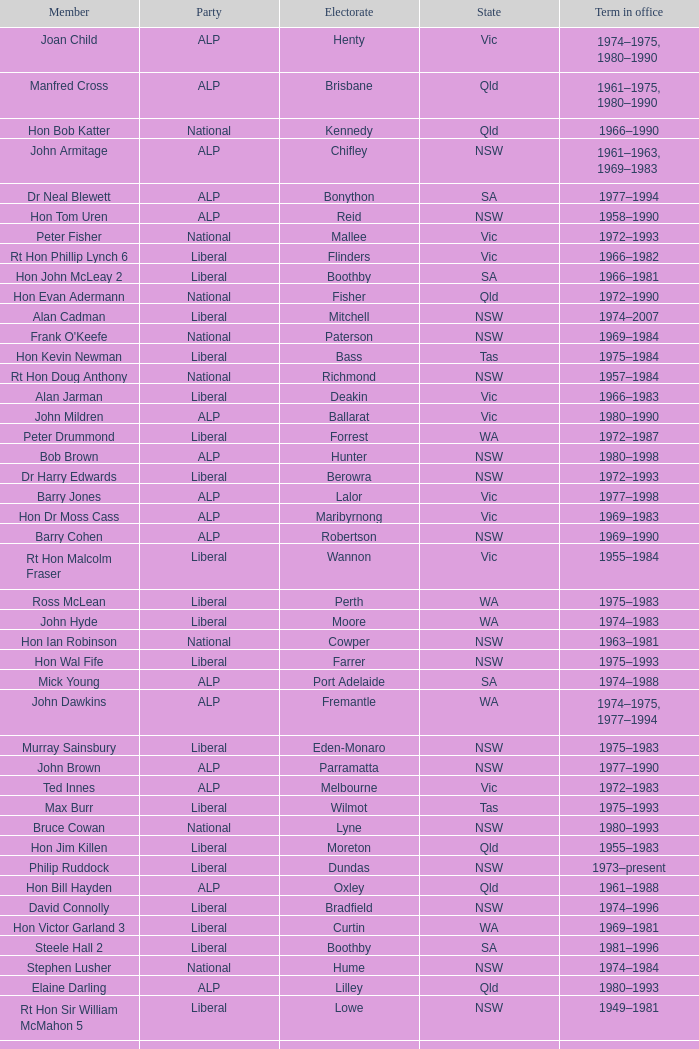Could you help me parse every detail presented in this table? {'header': ['Member', 'Party', 'Electorate', 'State', 'Term in office'], 'rows': [['Joan Child', 'ALP', 'Henty', 'Vic', '1974–1975, 1980–1990'], ['Manfred Cross', 'ALP', 'Brisbane', 'Qld', '1961–1975, 1980–1990'], ['Hon Bob Katter', 'National', 'Kennedy', 'Qld', '1966–1990'], ['John Armitage', 'ALP', 'Chifley', 'NSW', '1961–1963, 1969–1983'], ['Dr Neal Blewett', 'ALP', 'Bonython', 'SA', '1977–1994'], ['Hon Tom Uren', 'ALP', 'Reid', 'NSW', '1958–1990'], ['Peter Fisher', 'National', 'Mallee', 'Vic', '1972–1993'], ['Rt Hon Phillip Lynch 6', 'Liberal', 'Flinders', 'Vic', '1966–1982'], ['Hon John McLeay 2', 'Liberal', 'Boothby', 'SA', '1966–1981'], ['Hon Evan Adermann', 'National', 'Fisher', 'Qld', '1972–1990'], ['Alan Cadman', 'Liberal', 'Mitchell', 'NSW', '1974–2007'], ["Frank O'Keefe", 'National', 'Paterson', 'NSW', '1969–1984'], ['Hon Kevin Newman', 'Liberal', 'Bass', 'Tas', '1975–1984'], ['Rt Hon Doug Anthony', 'National', 'Richmond', 'NSW', '1957–1984'], ['Alan Jarman', 'Liberal', 'Deakin', 'Vic', '1966–1983'], ['John Mildren', 'ALP', 'Ballarat', 'Vic', '1980–1990'], ['Peter Drummond', 'Liberal', 'Forrest', 'WA', '1972–1987'], ['Bob Brown', 'ALP', 'Hunter', 'NSW', '1980–1998'], ['Dr Harry Edwards', 'Liberal', 'Berowra', 'NSW', '1972–1993'], ['Barry Jones', 'ALP', 'Lalor', 'Vic', '1977–1998'], ['Hon Dr Moss Cass', 'ALP', 'Maribyrnong', 'Vic', '1969–1983'], ['Barry Cohen', 'ALP', 'Robertson', 'NSW', '1969–1990'], ['Rt Hon Malcolm Fraser', 'Liberal', 'Wannon', 'Vic', '1955–1984'], ['Ross McLean', 'Liberal', 'Perth', 'WA', '1975–1983'], ['John Hyde', 'Liberal', 'Moore', 'WA', '1974–1983'], ['Hon Ian Robinson', 'National', 'Cowper', 'NSW', '1963–1981'], ['Hon Wal Fife', 'Liberal', 'Farrer', 'NSW', '1975–1993'], ['Mick Young', 'ALP', 'Port Adelaide', 'SA', '1974–1988'], ['John Dawkins', 'ALP', 'Fremantle', 'WA', '1974–1975, 1977–1994'], ['Murray Sainsbury', 'Liberal', 'Eden-Monaro', 'NSW', '1975–1983'], ['John Brown', 'ALP', 'Parramatta', 'NSW', '1977–1990'], ['Ted Innes', 'ALP', 'Melbourne', 'Vic', '1972–1983'], ['Max Burr', 'Liberal', 'Wilmot', 'Tas', '1975–1993'], ['Bruce Cowan', 'National', 'Lyne', 'NSW', '1980–1993'], ['Hon Jim Killen', 'Liberal', 'Moreton', 'Qld', '1955–1983'], ['Philip Ruddock', 'Liberal', 'Dundas', 'NSW', '1973–present'], ['Hon Bill Hayden', 'ALP', 'Oxley', 'Qld', '1961–1988'], ['David Connolly', 'Liberal', 'Bradfield', 'NSW', '1974–1996'], ['Hon Victor Garland 3', 'Liberal', 'Curtin', 'WA', '1969–1981'], ['Steele Hall 2', 'Liberal', 'Boothby', 'SA', '1981–1996'], ['Stephen Lusher', 'National', 'Hume', 'NSW', '1974–1984'], ['Elaine Darling', 'ALP', 'Lilley', 'Qld', '1980–1993'], ['Rt Hon Sir William McMahon 5', 'Liberal', 'Lowe', 'NSW', '1949–1981'], ['John Spender', 'Liberal', 'North Sydney', 'NSW', '1980–1990'], ['Ben Humphreys', 'ALP', 'Griffith', 'Qld', '1977–1996'], ['Ralph Willis', 'ALP', 'Gellibrand', 'Vic', '1972–1998'], ['Hon Robert Ellicott 4', 'Liberal', 'Wentworth', 'NSW', '1974–1981'], ['John Scott', 'ALP', 'Hindmarsh', 'SA', '1980–1993'], ['Jack Birney', 'Liberal', 'Phillip', 'NSW', '1975–1983'], ['Brian Howe', 'ALP', 'Batman', 'Vic', '1977–1996'], ['Grant Tambling', 'CLP', 'Northern Territory', 'NT', '1980–1983'], ['Hon Les Johnson', 'ALP', 'Hughes', 'NSW', '1955–1966, 1969–1984'], ['Hon Peter Nixon', 'National', 'Gippsland', 'Vic', '1961–1983'], ['Grant Chapman', 'Liberal', 'Kingston', 'SA', '1975–1983'], ['Hon Don Dobie', 'Liberal', 'Cook', 'NSW', '1966–1972, 1975–1996'], ['Hon Charles Jones', 'ALP', 'Newcastle', 'NSW', '1958–1983'], ['Hon Michael MacKellar', 'Liberal', 'Warringah', 'NSW', '1969–1994'], ['Ray Braithwaite', 'National', 'Dawson', 'Qld', '1975–1996'], ['Peter Shack', 'Liberal', 'Tangney', 'WA', '1977–1983, 1984–1993'], ['Ewen Cameron', 'Liberal', 'Indi', 'Vic', '1977–1993'], ['Leslie McMahon', 'ALP', 'Sydney', 'NSW', '1975–1983'], ['Roger Shipton', 'Liberal', 'Higgins', 'Vic', '1975–1990'], ['Graeme Campbell', 'ALP', 'Kalgoorlie', 'WA', '1980–1998'], ['Donald Milner Cameron', 'Liberal', 'Fadden', 'Qld', '1966–1990'], ['Dr Dick Klugman', 'ALP', 'Prospect', 'NSW', '1969–1990'], ['Sandy Mackenzie', 'National', 'Calare', 'NSW', '1975–1983'], ['Bruce Lloyd', 'National', 'Murray', 'Vic', '1971–1996'], ['Hon Ray Groom', 'Liberal', 'Braddon', 'Tas', '1975–1984'], ['Geoffrey Giles', 'Liberal', 'Wakefield', 'SA', '1964–1983'], ['Ralph Jacobi', 'ALP', 'Hawker', 'SA', '1969–1987'], ['Hon Ian Macphee', 'Liberal', 'Balaclava', 'Vic', '1974–1990'], ['Peter Coleman 4', 'Liberal', 'Wentworth', 'NSW', '1981–1987'], ['Stewart West', 'ALP', 'Cunningham', 'NSW', '1977–1993'], ['Ian Cameron', 'National', 'Maranoa', 'Qld', '1980–1990'], ['Michael Hodgman', 'Liberal', 'Denison', 'Tas', '1975–1987'], ['Peter Morris', 'ALP', 'Shortland', 'NSW', '1972–1998'], ['Tom McVeigh', 'National', 'Darling Downs', 'Qld', '1972–1988'], ['Wilson Tuckey', 'Liberal', "O'Connor", 'WA', '1980–2010'], ['Michael Baume', 'Liberal', 'Macarthur', 'NSW', '1975–1983'], ['Dr Andrew Theophanous', 'ALP', 'Burke', 'Vic', '1980–2001'], ['John Mountford', 'ALP', 'Banks', 'NSW', '1980–1990'], ['Allan Rocher 3', 'Liberal', 'Curtin', 'WA', '1981–1998'], ['Peter White 1', 'Liberal', 'McPherson', 'Qld', '1981–1990'], ['Peter Reith 6', 'Liberal', 'Flinders', 'Vic', '1982–1983, 1984–2001'], ['Noel Hicks', 'National', 'Riverina', 'NSW', '1980–1998'], ['Peter Falconer', 'Liberal', 'Casey', 'Vic', '1975–1983'], ['Ken Fry', 'ALP', 'Fraser', 'ACT', '1974–1984'], ['Hon David Thomson', 'National', 'Leichhardt', 'Qld', '1975–1983'], ['Rt Hon Ian Sinclair', 'National', 'New England', 'NSW', '1963–1998'], ['Bruce Goodluck', 'Liberal', 'Franklin', 'Tas', '1975–1993'], ['Laurie Wallis', 'ALP', 'Grey', 'SA', '1969–1983'], ['Hon Bill Morrison', 'ALP', 'St George', 'NSW', '1969–1975, 1980–1984'], ['Kim Beazley', 'ALP', 'Swan', 'WA', '1980–2007'], ['Leo McLeay', 'ALP', 'Grayndler', 'NSW', '1979–2004'], ['Bob Hawke', 'ALP', 'Wills', 'Vic', '1980–1992'], ['Michael Duffy', 'ALP', 'Holt', 'Vic', '1980–1996'], ['Lewis Kent', 'ALP', 'Hotham', 'Vic', '1980–1990'], ['Graham Harris', 'Liberal', 'Chisholm', 'Vic', '1980–1983'], ['Hon John Howard', 'Liberal', 'Bennelong', 'NSW', '1974–2007'], ['Ian Wilson', 'Liberal', 'Sturt', 'SA', '1966–1969, 1972–1993'], ['John Moore', 'Liberal', 'Ryan', 'Qld', '1975–2001'], ['Jim Carlton', 'Liberal', 'Mackellar', 'NSW', '1977–1994'], ['Clyde Holding', 'ALP', 'Melbourne Ports', 'Vic', '1977–1998'], ['Hon Eric Robinson 1', 'Liberal', 'McPherson', 'Qld', '1972–1990'], ['Hon Ralph Hunt', 'National', 'Gwydir', 'NSW', '1969–1989'], ['Hon Andrew Peacock', 'Liberal', 'Kooyong', 'Vic', '1966–1994'], ['Hon Ian Viner', 'Liberal', 'Stirling', 'WA', '1972–1983'], ['David Charles', 'ALP', 'Isaacs', 'Vic', '1980–1990'], ['Hon Tony Street', 'Liberal', 'Corangamite', 'Vic', '1966–1984'], ['Dr Harry Jenkins', 'ALP', 'Scullin', 'Vic', '1969–1985'], ['Hon Paul Keating', 'ALP', 'Blaxland', 'NSW', '1969–1996'], ['Clarrie Millar', 'National', 'Wide Bay', 'Qld', '1974–1990'], ['Michael Maher 5', 'ALP', 'Lowe', 'NSW', '1982–1987'], ['Hon Dr Doug Everingham', 'ALP', 'Capricornia', 'Qld', '1967–1975, 1977–1984'], ['Barry Cunningham', 'ALP', 'McMillan', 'Vic', '1980–1990, 1993–1996'], ['Hon Lionel Bowen', 'ALP', 'Kingsford-Smith', 'NSW', '1969–1990'], ['Jim Bradfield', 'Liberal', 'Barton', 'NSW', '1975–1983'], ['Hon Gordon Scholes', 'ALP', 'Corio', 'Vic', '1967–1993'], ['Rt Hon Sir Billy Snedden', 'Liberal', 'Bruce', 'Vic', '1955–1983'], ['John Hodges', 'Liberal', 'Petrie', 'Qld', '1974–1983, 1984–1987'], ['Gordon Dean', 'Liberal', 'Herbert', 'Qld', '1977–1983'], ['Ros Kelly', 'ALP', 'Canberra', 'ACT', '1980–1995'], ['Chris Hurford', 'ALP', 'Adelaide', 'SA', '1969–1988'], ['Ross Free', 'ALP', 'Macquarie', 'NSW', '1980–1996'], ['John Kerin', 'ALP', 'Werriwa', 'NSW', '1972–1975, 1978–1994'], ['David Jull', 'Liberal', 'Bowman', 'Qld', '1975–1983, 1984–2007'], ['Mel Bungey', 'Liberal', 'Canning', 'WA', '1974–1983'], ['James Porter', 'Liberal', 'Barker', 'SA', '1975–1990'], ['Neil Brown', 'Liberal', 'Diamond Valley', 'Vic', '1969–1972, 1975–1991'], ['John Bourchier', 'Liberal', 'Bendigo', 'Vic', '1972–1983'], ['Peter Milton', 'ALP', 'La Trobe', 'Vic', '1980–1990']]} What party is Mick Young a member of? ALP. 